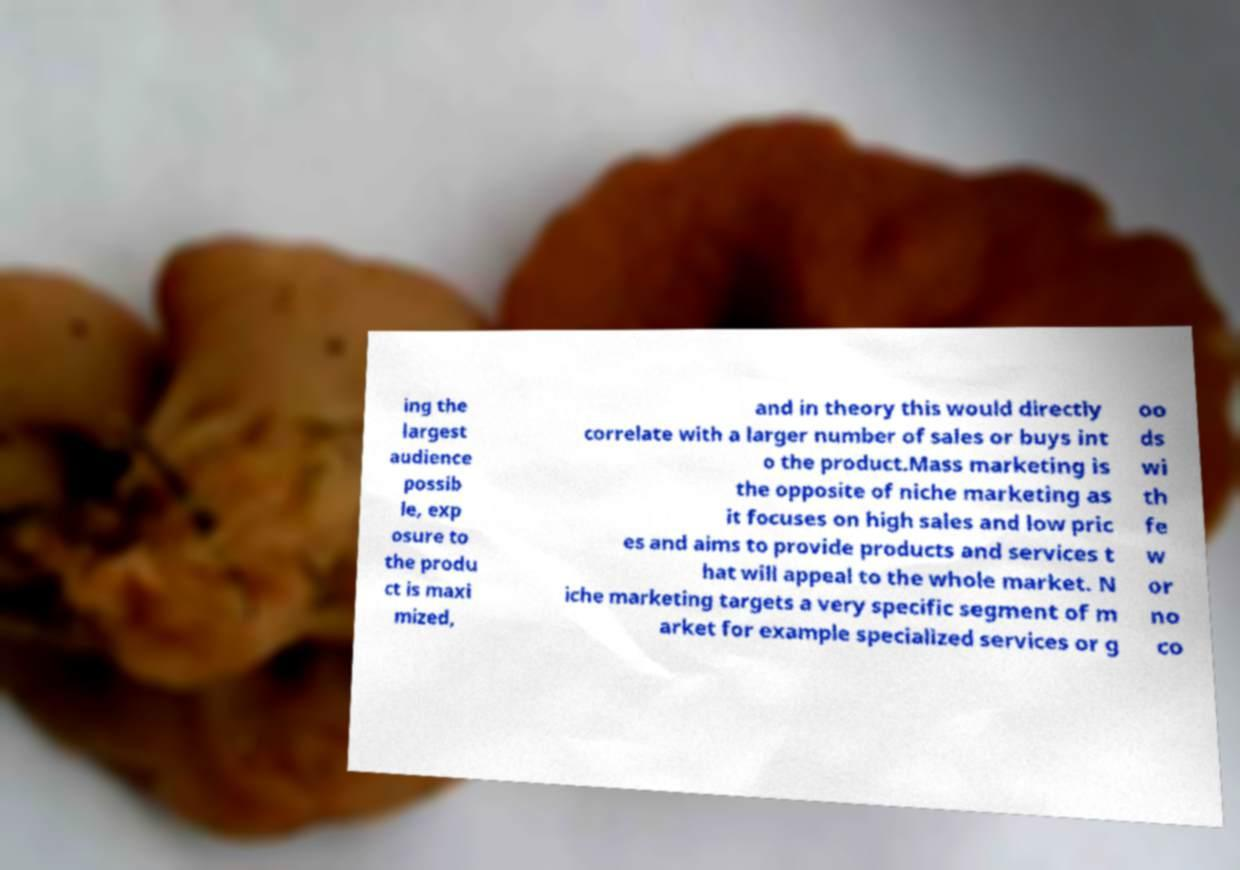Could you extract and type out the text from this image? ing the largest audience possib le, exp osure to the produ ct is maxi mized, and in theory this would directly correlate with a larger number of sales or buys int o the product.Mass marketing is the opposite of niche marketing as it focuses on high sales and low pric es and aims to provide products and services t hat will appeal to the whole market. N iche marketing targets a very specific segment of m arket for example specialized services or g oo ds wi th fe w or no co 